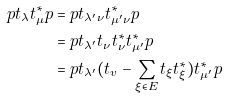Convert formula to latex. <formula><loc_0><loc_0><loc_500><loc_500>p t _ { \lambda } t _ { \mu } ^ { * } p & = p t _ { \lambda ^ { \prime } \nu } t _ { \mu ^ { \prime } \nu } ^ { * } p \\ & = p t _ { \lambda ^ { \prime } } t _ { \nu } t _ { \nu } ^ { * } t _ { \mu ^ { \prime } } ^ { * } p \\ & = p t _ { \lambda ^ { \prime } } ( t _ { v } - \sum _ { \xi \in E } t _ { \xi } t _ { \xi } ^ { * } ) t _ { \mu ^ { \prime } } ^ { * } p \\</formula> 